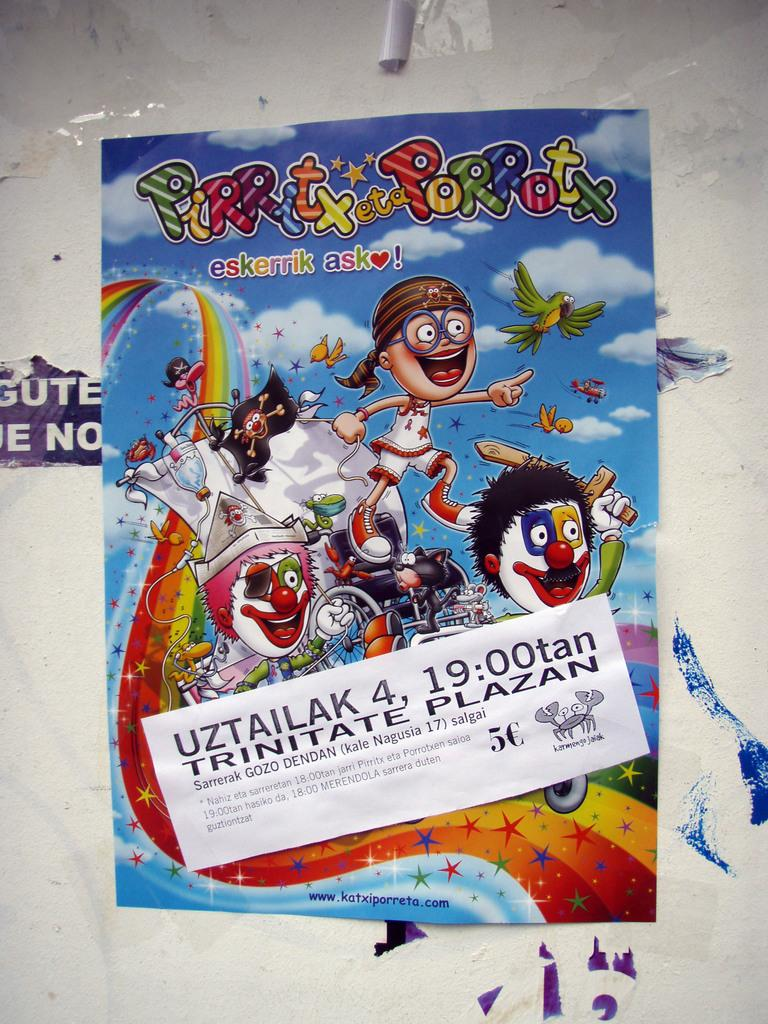<image>
Offer a succinct explanation of the picture presented. A poster for a cartoon has the words Pirritx eta Porrotx on it. 